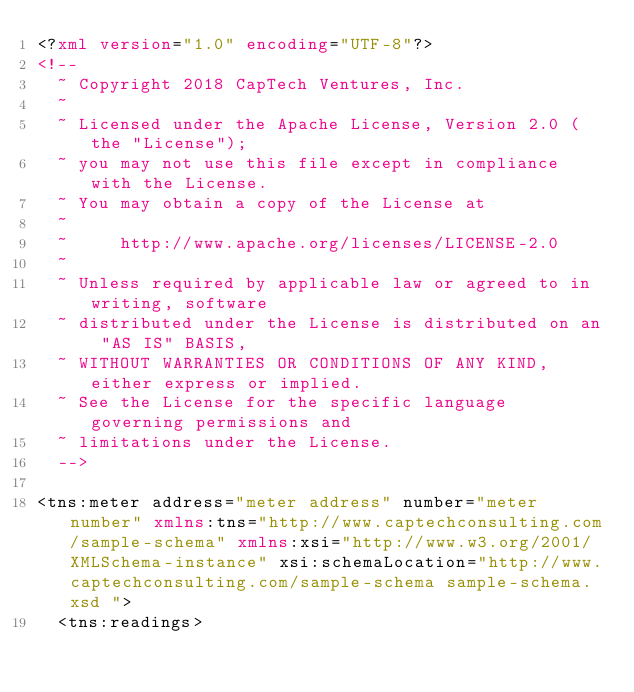Convert code to text. <code><loc_0><loc_0><loc_500><loc_500><_XML_><?xml version="1.0" encoding="UTF-8"?>
<!--
  ~ Copyright 2018 CapTech Ventures, Inc.
  ~
  ~ Licensed under the Apache License, Version 2.0 (the "License");
  ~ you may not use this file except in compliance with the License.
  ~ You may obtain a copy of the License at
  ~
  ~     http://www.apache.org/licenses/LICENSE-2.0
  ~
  ~ Unless required by applicable law or agreed to in writing, software
  ~ distributed under the License is distributed on an "AS IS" BASIS,
  ~ WITHOUT WARRANTIES OR CONDITIONS OF ANY KIND, either express or implied.
  ~ See the License for the specific language governing permissions and
  ~ limitations under the License.
  -->

<tns:meter address="meter address" number="meter number" xmlns:tns="http://www.captechconsulting.com/sample-schema" xmlns:xsi="http://www.w3.org/2001/XMLSchema-instance" xsi:schemaLocation="http://www.captechconsulting.com/sample-schema sample-schema.xsd ">
  <tns:readings></code> 